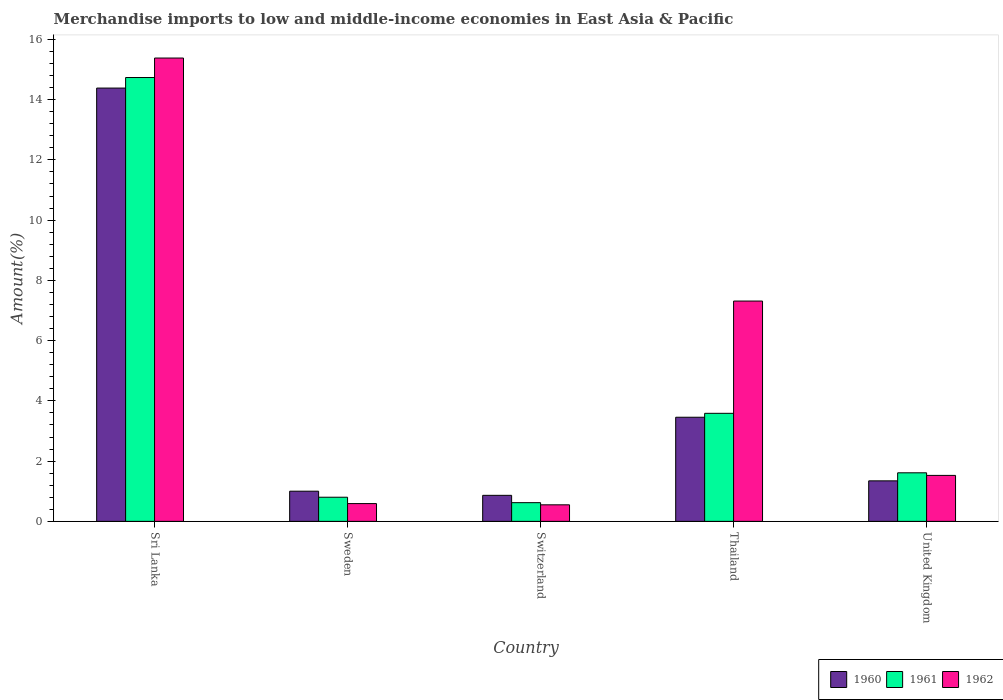How many groups of bars are there?
Give a very brief answer. 5. Are the number of bars on each tick of the X-axis equal?
Your answer should be compact. Yes. What is the label of the 2nd group of bars from the left?
Provide a short and direct response. Sweden. In how many cases, is the number of bars for a given country not equal to the number of legend labels?
Offer a very short reply. 0. What is the percentage of amount earned from merchandise imports in 1962 in Sri Lanka?
Ensure brevity in your answer.  15.38. Across all countries, what is the maximum percentage of amount earned from merchandise imports in 1960?
Offer a very short reply. 14.38. Across all countries, what is the minimum percentage of amount earned from merchandise imports in 1961?
Your response must be concise. 0.62. In which country was the percentage of amount earned from merchandise imports in 1962 maximum?
Offer a terse response. Sri Lanka. In which country was the percentage of amount earned from merchandise imports in 1962 minimum?
Provide a succinct answer. Switzerland. What is the total percentage of amount earned from merchandise imports in 1960 in the graph?
Keep it short and to the point. 21.05. What is the difference between the percentage of amount earned from merchandise imports in 1960 in Sri Lanka and that in Thailand?
Give a very brief answer. 10.93. What is the difference between the percentage of amount earned from merchandise imports in 1960 in Thailand and the percentage of amount earned from merchandise imports in 1961 in Sweden?
Offer a terse response. 2.65. What is the average percentage of amount earned from merchandise imports in 1962 per country?
Ensure brevity in your answer.  5.07. What is the difference between the percentage of amount earned from merchandise imports of/in 1962 and percentage of amount earned from merchandise imports of/in 1961 in Switzerland?
Provide a succinct answer. -0.07. In how many countries, is the percentage of amount earned from merchandise imports in 1960 greater than 6.4 %?
Your response must be concise. 1. What is the ratio of the percentage of amount earned from merchandise imports in 1962 in Sweden to that in United Kingdom?
Your response must be concise. 0.39. Is the percentage of amount earned from merchandise imports in 1962 in Sweden less than that in Thailand?
Provide a succinct answer. Yes. Is the difference between the percentage of amount earned from merchandise imports in 1962 in Sweden and Thailand greater than the difference between the percentage of amount earned from merchandise imports in 1961 in Sweden and Thailand?
Your response must be concise. No. What is the difference between the highest and the second highest percentage of amount earned from merchandise imports in 1960?
Offer a very short reply. -2.11. What is the difference between the highest and the lowest percentage of amount earned from merchandise imports in 1961?
Give a very brief answer. 14.11. In how many countries, is the percentage of amount earned from merchandise imports in 1961 greater than the average percentage of amount earned from merchandise imports in 1961 taken over all countries?
Your answer should be very brief. 1. What does the 1st bar from the left in Sweden represents?
Offer a terse response. 1960. What does the 3rd bar from the right in Thailand represents?
Provide a short and direct response. 1960. Is it the case that in every country, the sum of the percentage of amount earned from merchandise imports in 1960 and percentage of amount earned from merchandise imports in 1962 is greater than the percentage of amount earned from merchandise imports in 1961?
Your answer should be very brief. Yes. Are all the bars in the graph horizontal?
Give a very brief answer. No. What is the difference between two consecutive major ticks on the Y-axis?
Offer a very short reply. 2. Does the graph contain any zero values?
Ensure brevity in your answer.  No. Does the graph contain grids?
Your answer should be very brief. No. How are the legend labels stacked?
Keep it short and to the point. Horizontal. What is the title of the graph?
Ensure brevity in your answer.  Merchandise imports to low and middle-income economies in East Asia & Pacific. What is the label or title of the X-axis?
Provide a short and direct response. Country. What is the label or title of the Y-axis?
Offer a very short reply. Amount(%). What is the Amount(%) in 1960 in Sri Lanka?
Offer a terse response. 14.38. What is the Amount(%) in 1961 in Sri Lanka?
Give a very brief answer. 14.73. What is the Amount(%) of 1962 in Sri Lanka?
Offer a terse response. 15.38. What is the Amount(%) of 1960 in Sweden?
Provide a short and direct response. 1. What is the Amount(%) of 1961 in Sweden?
Offer a very short reply. 0.8. What is the Amount(%) of 1962 in Sweden?
Your answer should be very brief. 0.59. What is the Amount(%) in 1960 in Switzerland?
Provide a succinct answer. 0.86. What is the Amount(%) in 1961 in Switzerland?
Offer a terse response. 0.62. What is the Amount(%) of 1962 in Switzerland?
Your answer should be compact. 0.55. What is the Amount(%) of 1960 in Thailand?
Provide a short and direct response. 3.46. What is the Amount(%) in 1961 in Thailand?
Give a very brief answer. 3.59. What is the Amount(%) of 1962 in Thailand?
Offer a very short reply. 7.31. What is the Amount(%) in 1960 in United Kingdom?
Give a very brief answer. 1.34. What is the Amount(%) of 1961 in United Kingdom?
Ensure brevity in your answer.  1.61. What is the Amount(%) of 1962 in United Kingdom?
Offer a terse response. 1.53. Across all countries, what is the maximum Amount(%) of 1960?
Offer a very short reply. 14.38. Across all countries, what is the maximum Amount(%) of 1961?
Your response must be concise. 14.73. Across all countries, what is the maximum Amount(%) in 1962?
Offer a very short reply. 15.38. Across all countries, what is the minimum Amount(%) in 1960?
Make the answer very short. 0.86. Across all countries, what is the minimum Amount(%) of 1961?
Make the answer very short. 0.62. Across all countries, what is the minimum Amount(%) in 1962?
Give a very brief answer. 0.55. What is the total Amount(%) of 1960 in the graph?
Your answer should be very brief. 21.05. What is the total Amount(%) in 1961 in the graph?
Your response must be concise. 21.35. What is the total Amount(%) in 1962 in the graph?
Your response must be concise. 25.36. What is the difference between the Amount(%) of 1960 in Sri Lanka and that in Sweden?
Provide a short and direct response. 13.38. What is the difference between the Amount(%) of 1961 in Sri Lanka and that in Sweden?
Ensure brevity in your answer.  13.93. What is the difference between the Amount(%) of 1962 in Sri Lanka and that in Sweden?
Provide a short and direct response. 14.79. What is the difference between the Amount(%) in 1960 in Sri Lanka and that in Switzerland?
Give a very brief answer. 13.52. What is the difference between the Amount(%) of 1961 in Sri Lanka and that in Switzerland?
Give a very brief answer. 14.11. What is the difference between the Amount(%) of 1962 in Sri Lanka and that in Switzerland?
Give a very brief answer. 14.83. What is the difference between the Amount(%) in 1960 in Sri Lanka and that in Thailand?
Provide a succinct answer. 10.93. What is the difference between the Amount(%) of 1961 in Sri Lanka and that in Thailand?
Offer a very short reply. 11.15. What is the difference between the Amount(%) of 1962 in Sri Lanka and that in Thailand?
Your answer should be compact. 8.07. What is the difference between the Amount(%) of 1960 in Sri Lanka and that in United Kingdom?
Give a very brief answer. 13.04. What is the difference between the Amount(%) of 1961 in Sri Lanka and that in United Kingdom?
Your response must be concise. 13.12. What is the difference between the Amount(%) of 1962 in Sri Lanka and that in United Kingdom?
Your response must be concise. 13.85. What is the difference between the Amount(%) in 1960 in Sweden and that in Switzerland?
Keep it short and to the point. 0.14. What is the difference between the Amount(%) in 1961 in Sweden and that in Switzerland?
Keep it short and to the point. 0.18. What is the difference between the Amount(%) of 1962 in Sweden and that in Switzerland?
Provide a short and direct response. 0.04. What is the difference between the Amount(%) in 1960 in Sweden and that in Thailand?
Provide a short and direct response. -2.45. What is the difference between the Amount(%) of 1961 in Sweden and that in Thailand?
Your answer should be compact. -2.79. What is the difference between the Amount(%) of 1962 in Sweden and that in Thailand?
Offer a very short reply. -6.72. What is the difference between the Amount(%) in 1960 in Sweden and that in United Kingdom?
Ensure brevity in your answer.  -0.34. What is the difference between the Amount(%) in 1961 in Sweden and that in United Kingdom?
Provide a succinct answer. -0.81. What is the difference between the Amount(%) of 1962 in Sweden and that in United Kingdom?
Your response must be concise. -0.94. What is the difference between the Amount(%) of 1960 in Switzerland and that in Thailand?
Ensure brevity in your answer.  -2.59. What is the difference between the Amount(%) in 1961 in Switzerland and that in Thailand?
Your answer should be very brief. -2.97. What is the difference between the Amount(%) in 1962 in Switzerland and that in Thailand?
Ensure brevity in your answer.  -6.76. What is the difference between the Amount(%) in 1960 in Switzerland and that in United Kingdom?
Provide a succinct answer. -0.48. What is the difference between the Amount(%) in 1961 in Switzerland and that in United Kingdom?
Your answer should be very brief. -0.99. What is the difference between the Amount(%) in 1962 in Switzerland and that in United Kingdom?
Offer a terse response. -0.98. What is the difference between the Amount(%) in 1960 in Thailand and that in United Kingdom?
Offer a very short reply. 2.11. What is the difference between the Amount(%) of 1961 in Thailand and that in United Kingdom?
Your answer should be very brief. 1.97. What is the difference between the Amount(%) in 1962 in Thailand and that in United Kingdom?
Provide a succinct answer. 5.79. What is the difference between the Amount(%) of 1960 in Sri Lanka and the Amount(%) of 1961 in Sweden?
Your response must be concise. 13.58. What is the difference between the Amount(%) of 1960 in Sri Lanka and the Amount(%) of 1962 in Sweden?
Provide a short and direct response. 13.79. What is the difference between the Amount(%) in 1961 in Sri Lanka and the Amount(%) in 1962 in Sweden?
Make the answer very short. 14.14. What is the difference between the Amount(%) of 1960 in Sri Lanka and the Amount(%) of 1961 in Switzerland?
Offer a very short reply. 13.76. What is the difference between the Amount(%) in 1960 in Sri Lanka and the Amount(%) in 1962 in Switzerland?
Give a very brief answer. 13.83. What is the difference between the Amount(%) in 1961 in Sri Lanka and the Amount(%) in 1962 in Switzerland?
Keep it short and to the point. 14.18. What is the difference between the Amount(%) of 1960 in Sri Lanka and the Amount(%) of 1961 in Thailand?
Provide a short and direct response. 10.8. What is the difference between the Amount(%) of 1960 in Sri Lanka and the Amount(%) of 1962 in Thailand?
Keep it short and to the point. 7.07. What is the difference between the Amount(%) in 1961 in Sri Lanka and the Amount(%) in 1962 in Thailand?
Your answer should be very brief. 7.42. What is the difference between the Amount(%) in 1960 in Sri Lanka and the Amount(%) in 1961 in United Kingdom?
Make the answer very short. 12.77. What is the difference between the Amount(%) in 1960 in Sri Lanka and the Amount(%) in 1962 in United Kingdom?
Ensure brevity in your answer.  12.86. What is the difference between the Amount(%) of 1961 in Sri Lanka and the Amount(%) of 1962 in United Kingdom?
Give a very brief answer. 13.21. What is the difference between the Amount(%) of 1960 in Sweden and the Amount(%) of 1961 in Switzerland?
Keep it short and to the point. 0.38. What is the difference between the Amount(%) of 1960 in Sweden and the Amount(%) of 1962 in Switzerland?
Provide a short and direct response. 0.45. What is the difference between the Amount(%) of 1961 in Sweden and the Amount(%) of 1962 in Switzerland?
Make the answer very short. 0.25. What is the difference between the Amount(%) in 1960 in Sweden and the Amount(%) in 1961 in Thailand?
Your answer should be very brief. -2.59. What is the difference between the Amount(%) of 1960 in Sweden and the Amount(%) of 1962 in Thailand?
Offer a very short reply. -6.31. What is the difference between the Amount(%) of 1961 in Sweden and the Amount(%) of 1962 in Thailand?
Offer a very short reply. -6.51. What is the difference between the Amount(%) in 1960 in Sweden and the Amount(%) in 1961 in United Kingdom?
Offer a very short reply. -0.61. What is the difference between the Amount(%) of 1960 in Sweden and the Amount(%) of 1962 in United Kingdom?
Provide a short and direct response. -0.52. What is the difference between the Amount(%) of 1961 in Sweden and the Amount(%) of 1962 in United Kingdom?
Your response must be concise. -0.72. What is the difference between the Amount(%) of 1960 in Switzerland and the Amount(%) of 1961 in Thailand?
Your answer should be compact. -2.72. What is the difference between the Amount(%) in 1960 in Switzerland and the Amount(%) in 1962 in Thailand?
Provide a short and direct response. -6.45. What is the difference between the Amount(%) in 1961 in Switzerland and the Amount(%) in 1962 in Thailand?
Provide a short and direct response. -6.69. What is the difference between the Amount(%) of 1960 in Switzerland and the Amount(%) of 1961 in United Kingdom?
Give a very brief answer. -0.75. What is the difference between the Amount(%) of 1960 in Switzerland and the Amount(%) of 1962 in United Kingdom?
Make the answer very short. -0.66. What is the difference between the Amount(%) of 1961 in Switzerland and the Amount(%) of 1962 in United Kingdom?
Provide a short and direct response. -0.91. What is the difference between the Amount(%) of 1960 in Thailand and the Amount(%) of 1961 in United Kingdom?
Give a very brief answer. 1.84. What is the difference between the Amount(%) in 1960 in Thailand and the Amount(%) in 1962 in United Kingdom?
Offer a terse response. 1.93. What is the difference between the Amount(%) of 1961 in Thailand and the Amount(%) of 1962 in United Kingdom?
Ensure brevity in your answer.  2.06. What is the average Amount(%) of 1960 per country?
Your answer should be very brief. 4.21. What is the average Amount(%) of 1961 per country?
Provide a short and direct response. 4.27. What is the average Amount(%) of 1962 per country?
Your response must be concise. 5.07. What is the difference between the Amount(%) of 1960 and Amount(%) of 1961 in Sri Lanka?
Offer a very short reply. -0.35. What is the difference between the Amount(%) in 1960 and Amount(%) in 1962 in Sri Lanka?
Give a very brief answer. -1. What is the difference between the Amount(%) of 1961 and Amount(%) of 1962 in Sri Lanka?
Make the answer very short. -0.65. What is the difference between the Amount(%) in 1960 and Amount(%) in 1961 in Sweden?
Make the answer very short. 0.2. What is the difference between the Amount(%) in 1960 and Amount(%) in 1962 in Sweden?
Offer a terse response. 0.41. What is the difference between the Amount(%) in 1961 and Amount(%) in 1962 in Sweden?
Provide a succinct answer. 0.21. What is the difference between the Amount(%) of 1960 and Amount(%) of 1961 in Switzerland?
Your answer should be very brief. 0.24. What is the difference between the Amount(%) of 1960 and Amount(%) of 1962 in Switzerland?
Your answer should be compact. 0.31. What is the difference between the Amount(%) of 1961 and Amount(%) of 1962 in Switzerland?
Give a very brief answer. 0.07. What is the difference between the Amount(%) in 1960 and Amount(%) in 1961 in Thailand?
Give a very brief answer. -0.13. What is the difference between the Amount(%) of 1960 and Amount(%) of 1962 in Thailand?
Your answer should be very brief. -3.86. What is the difference between the Amount(%) of 1961 and Amount(%) of 1962 in Thailand?
Make the answer very short. -3.73. What is the difference between the Amount(%) of 1960 and Amount(%) of 1961 in United Kingdom?
Your answer should be compact. -0.27. What is the difference between the Amount(%) in 1960 and Amount(%) in 1962 in United Kingdom?
Make the answer very short. -0.18. What is the difference between the Amount(%) in 1961 and Amount(%) in 1962 in United Kingdom?
Make the answer very short. 0.09. What is the ratio of the Amount(%) in 1960 in Sri Lanka to that in Sweden?
Your answer should be compact. 14.36. What is the ratio of the Amount(%) in 1961 in Sri Lanka to that in Sweden?
Provide a short and direct response. 18.38. What is the ratio of the Amount(%) of 1962 in Sri Lanka to that in Sweden?
Offer a terse response. 26.07. What is the ratio of the Amount(%) in 1960 in Sri Lanka to that in Switzerland?
Provide a short and direct response. 16.64. What is the ratio of the Amount(%) of 1961 in Sri Lanka to that in Switzerland?
Give a very brief answer. 23.74. What is the ratio of the Amount(%) of 1962 in Sri Lanka to that in Switzerland?
Provide a short and direct response. 28. What is the ratio of the Amount(%) in 1960 in Sri Lanka to that in Thailand?
Ensure brevity in your answer.  4.16. What is the ratio of the Amount(%) of 1961 in Sri Lanka to that in Thailand?
Offer a very short reply. 4.11. What is the ratio of the Amount(%) in 1962 in Sri Lanka to that in Thailand?
Provide a succinct answer. 2.1. What is the ratio of the Amount(%) in 1960 in Sri Lanka to that in United Kingdom?
Provide a succinct answer. 10.69. What is the ratio of the Amount(%) of 1961 in Sri Lanka to that in United Kingdom?
Your answer should be compact. 9.14. What is the ratio of the Amount(%) of 1962 in Sri Lanka to that in United Kingdom?
Ensure brevity in your answer.  10.08. What is the ratio of the Amount(%) in 1960 in Sweden to that in Switzerland?
Give a very brief answer. 1.16. What is the ratio of the Amount(%) of 1961 in Sweden to that in Switzerland?
Give a very brief answer. 1.29. What is the ratio of the Amount(%) of 1962 in Sweden to that in Switzerland?
Offer a terse response. 1.07. What is the ratio of the Amount(%) of 1960 in Sweden to that in Thailand?
Your answer should be very brief. 0.29. What is the ratio of the Amount(%) of 1961 in Sweden to that in Thailand?
Offer a very short reply. 0.22. What is the ratio of the Amount(%) of 1962 in Sweden to that in Thailand?
Your answer should be very brief. 0.08. What is the ratio of the Amount(%) in 1960 in Sweden to that in United Kingdom?
Provide a succinct answer. 0.74. What is the ratio of the Amount(%) in 1961 in Sweden to that in United Kingdom?
Provide a short and direct response. 0.5. What is the ratio of the Amount(%) in 1962 in Sweden to that in United Kingdom?
Your answer should be very brief. 0.39. What is the ratio of the Amount(%) of 1960 in Switzerland to that in Thailand?
Make the answer very short. 0.25. What is the ratio of the Amount(%) in 1961 in Switzerland to that in Thailand?
Make the answer very short. 0.17. What is the ratio of the Amount(%) in 1962 in Switzerland to that in Thailand?
Make the answer very short. 0.08. What is the ratio of the Amount(%) of 1960 in Switzerland to that in United Kingdom?
Offer a terse response. 0.64. What is the ratio of the Amount(%) in 1961 in Switzerland to that in United Kingdom?
Your answer should be compact. 0.39. What is the ratio of the Amount(%) of 1962 in Switzerland to that in United Kingdom?
Your answer should be very brief. 0.36. What is the ratio of the Amount(%) in 1960 in Thailand to that in United Kingdom?
Your response must be concise. 2.57. What is the ratio of the Amount(%) in 1961 in Thailand to that in United Kingdom?
Make the answer very short. 2.23. What is the ratio of the Amount(%) of 1962 in Thailand to that in United Kingdom?
Keep it short and to the point. 4.79. What is the difference between the highest and the second highest Amount(%) of 1960?
Your response must be concise. 10.93. What is the difference between the highest and the second highest Amount(%) of 1961?
Your answer should be very brief. 11.15. What is the difference between the highest and the second highest Amount(%) of 1962?
Ensure brevity in your answer.  8.07. What is the difference between the highest and the lowest Amount(%) of 1960?
Keep it short and to the point. 13.52. What is the difference between the highest and the lowest Amount(%) in 1961?
Give a very brief answer. 14.11. What is the difference between the highest and the lowest Amount(%) of 1962?
Offer a terse response. 14.83. 